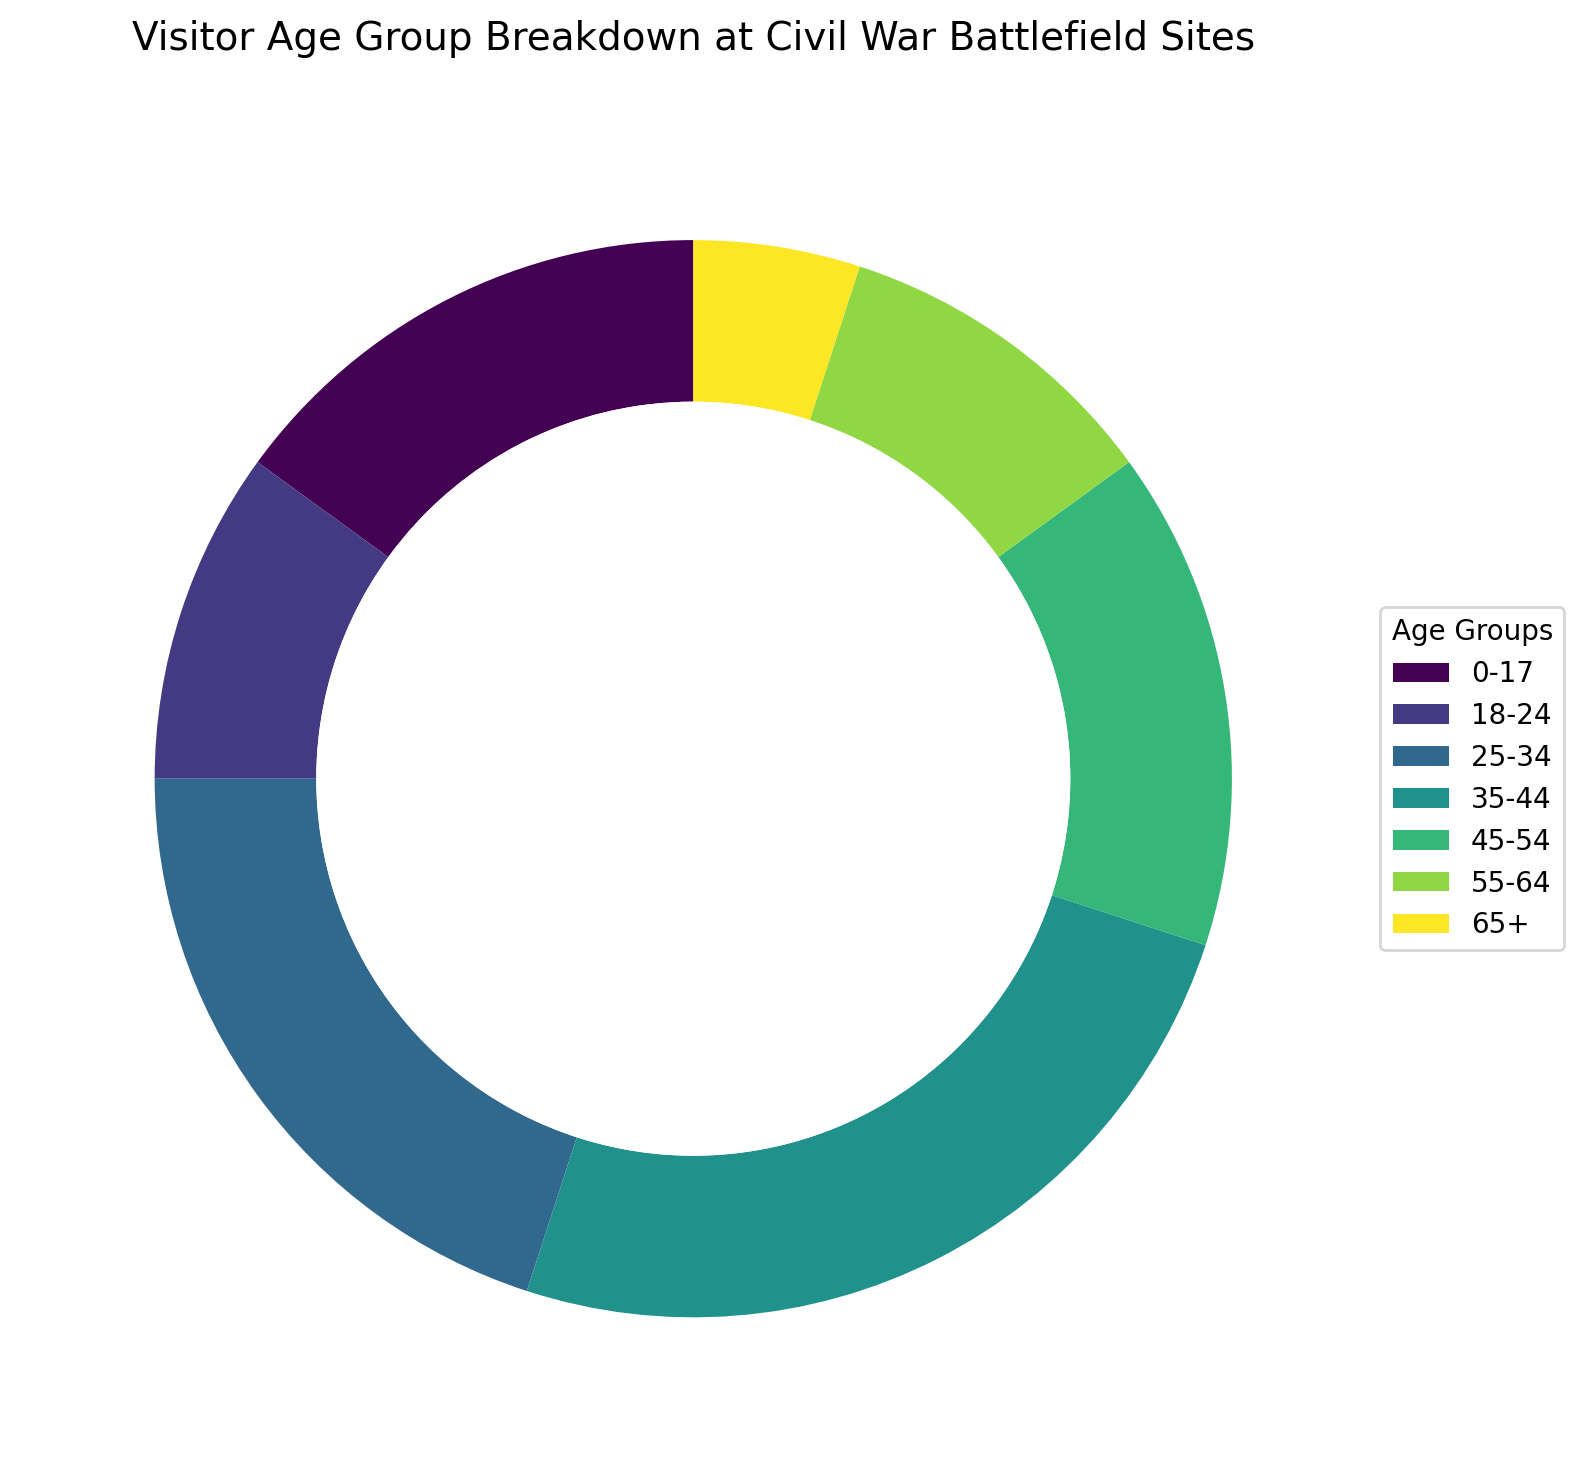What is the largest age group visiting the Civil War Battlefield sites? The figure shows various age groups with their corresponding percentages. "35-44" has the highest wedge, representing the largest age group.
Answer: 35-44 Which age group has the smallest percentage of visitors? By observing the wedges, the smallest wedge corresponds to the age group "65+" with 5%.
Answer: 65+ What is the combined percentage of visitors aged 18-24 and 55-64? Add the percentages for the age groups "18-24" and "55-64". That is 10% + 10% = 20%.
Answer: 20% How does the percentage of visitors aged 0-17 compare to those aged 45-54? The wedge for "0-17" shows 15%, and the wedge for "45-54" shows 15%. Both percentages are equal.
Answer: Equal Which age group has the second-largest percentage of visitors? After analyzing the wedges by size, the "35-44" age group is the largest, and "25-34" is the second-largest with 20%.
Answer: 25-34 Is the percentage of visitors aged 25-34 greater than or less than the sum of those aged 18-24 and 55-64? Add the percentages for "18-24" and "55-64" (10% + 10% = 20%). The percentage for "25-34" is also 20%, making them equal.
Answer: Equal What is the visual attribute that indicates the age group "45-54" in the ring chart? In the figure, each age group is represented by different segments (wedges) of the ring with unique colors. "45-54" has its own wedge with a distinct color.
Answer: Distinct colored wedge What is the combined percentage of visitors aged under 25? Sum the percentages for "0-17" and "18-24". That is 15% + 10% = 25%.
Answer: 25% How does the percentage of visitors aged 35-44 compare with those aged 65+? By comparing their wedges, "35-44" has a percentage of 25%, and "65+" has 5%. "35-44" has a higher percentage.
Answer: Higher 